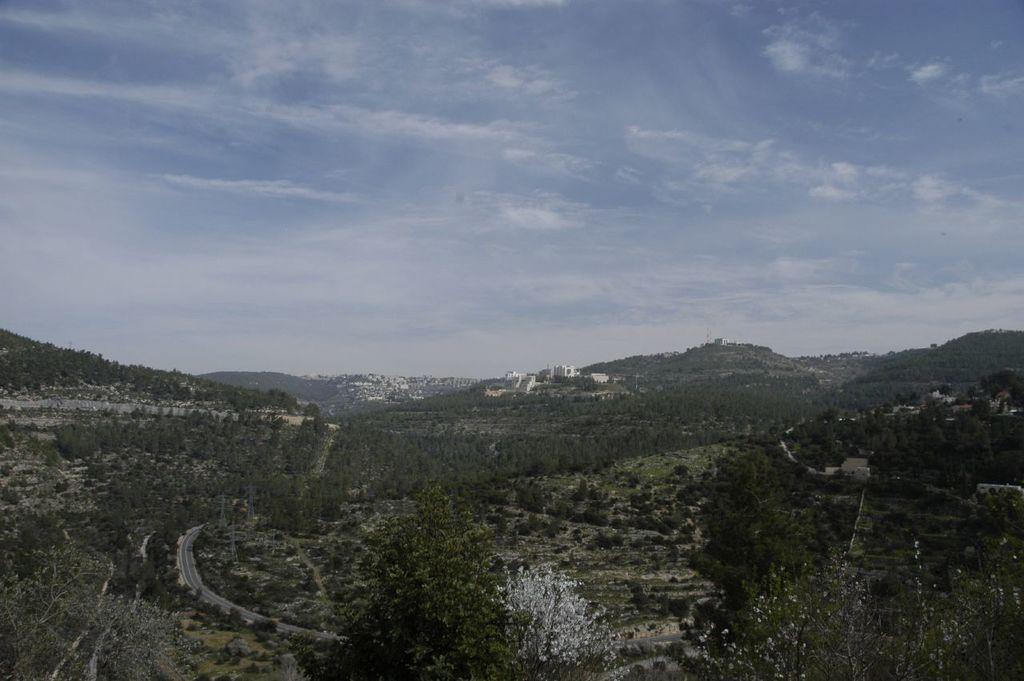Can you describe this image briefly? In this image I can see few trees, the ground, the road and few buildings. In the background I can see few mountains and the sky. 